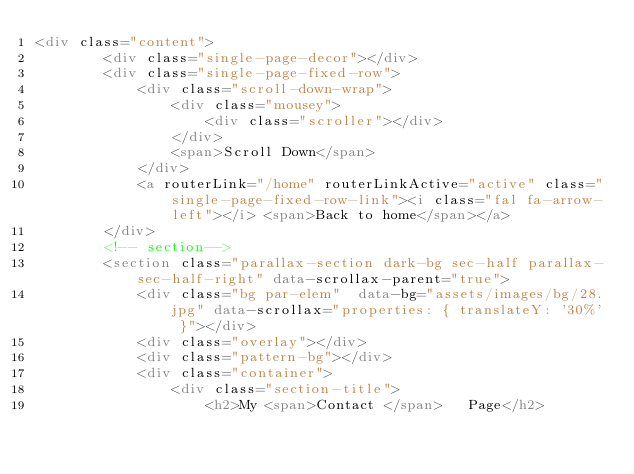Convert code to text. <code><loc_0><loc_0><loc_500><loc_500><_HTML_><div class="content">
        <div class="single-page-decor"></div>
        <div class="single-page-fixed-row">
            <div class="scroll-down-wrap">
                <div class="mousey">
                    <div class="scroller"></div>
                </div>
                <span>Scroll Down</span>
            </div>
            <a routerLink="/home" routerLinkActive="active" class="single-page-fixed-row-link"><i class="fal fa-arrow-left"></i> <span>Back to home</span></a>
        </div>
        <!-- section-->
        <section class="parallax-section dark-bg sec-half parallax-sec-half-right" data-scrollax-parent="true">
            <div class="bg par-elem"  data-bg="assets/images/bg/28.jpg" data-scrollax="properties: { translateY: '30%' }"></div>
            <div class="overlay"></div>
            <div class="pattern-bg"></div>
            <div class="container">
                <div class="section-title">
                    <h2>My <span>Contact </span>   Page</h2></code> 